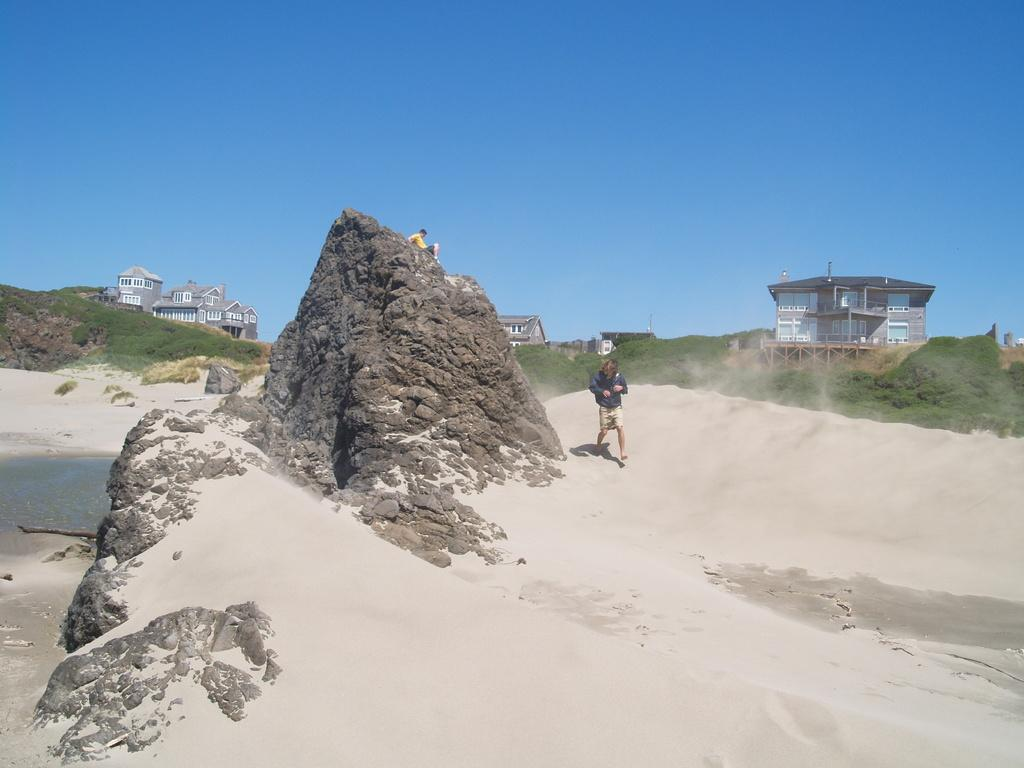What is the person in the foreground of the image doing? There is a person walking on the sand in the image. Where is the other person located in the image? The other person is sitting on a rock in the image. What can be seen in the background of the image? Buildings, windows, poles, plants, and the sky are visible in the background of the image. What type of roof can be seen on the buildings in the person in the image? There is no roof visible in the image, as it only shows people and the surrounding environment. 